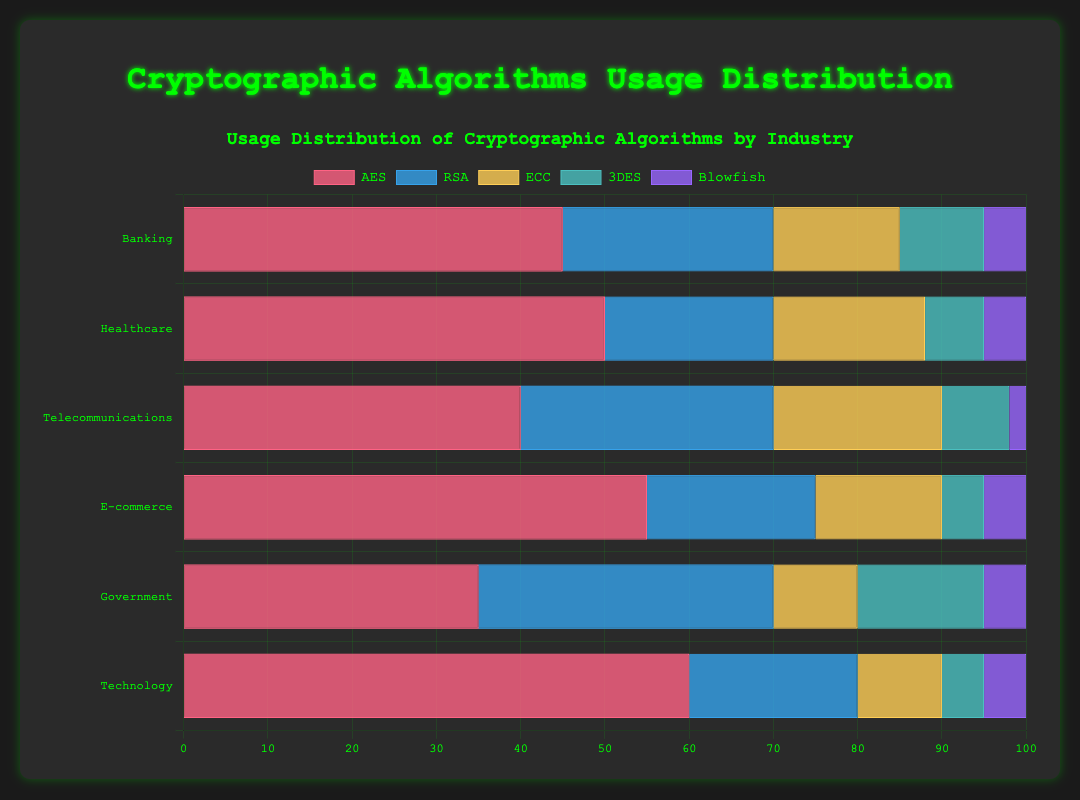Which industry has the highest usage of AES? By inspecting the bars for AES, the Technology industry has the tallest bar, indicating the highest usage. The value is 60.
Answer: Technology Which algorithm is used the least across all industries? By checking the lengths of all bars across industries, Blowfish consistently has shorter bars compared to other algorithms. It appears in small values across all industries.
Answer: Blowfish Which two industries have the same percentage for RSA? By comparing the bars for RSA across industries, Banking and Government show equal bar lengths for RSA, each with a value of 35.
Answer: Banking and Government What's the total usage percentage of AES in Banking and E-commerce combined? The AES usage percentage in Banking is 45 and in E-commerce is 55. Summing these gives 45 + 55 = 100.
Answer: 100 In which industry is ECC used more than 3DES but less than RSA? In Healthcare, the values for ECC, 3DES, and RSA are 18, 7, and 20 respectively. ECC is greater than 3DES but less than RSA.
Answer: Healthcare What's the difference in AES usage between the Telecommunications and Government sectors? The AES usage in Telecommunications is 40 and in Government is 35. The difference is 40 - 35 = 5.
Answer: 5 Which algorithm has the most uniform distribution across all industries? By comparing bar lengths, Blowfish has fairly equal small bars across all industries, indicating a uniform distribution.
Answer: Blowfish What is the average usage percentage of RSA across all listed industries? Summing the RSA values (25 + 20 + 30 + 20 + 35 + 20) and dividing by 6, gives (150 / 6) = 25.
Answer: 25 What is the ratio of AES to Blowfish usage in the Technology industry? The AES usage in Technology is 60 and Blowfish is 5, so the ratio is 60:5, which simplifies to 12:1.
Answer: 12:1 